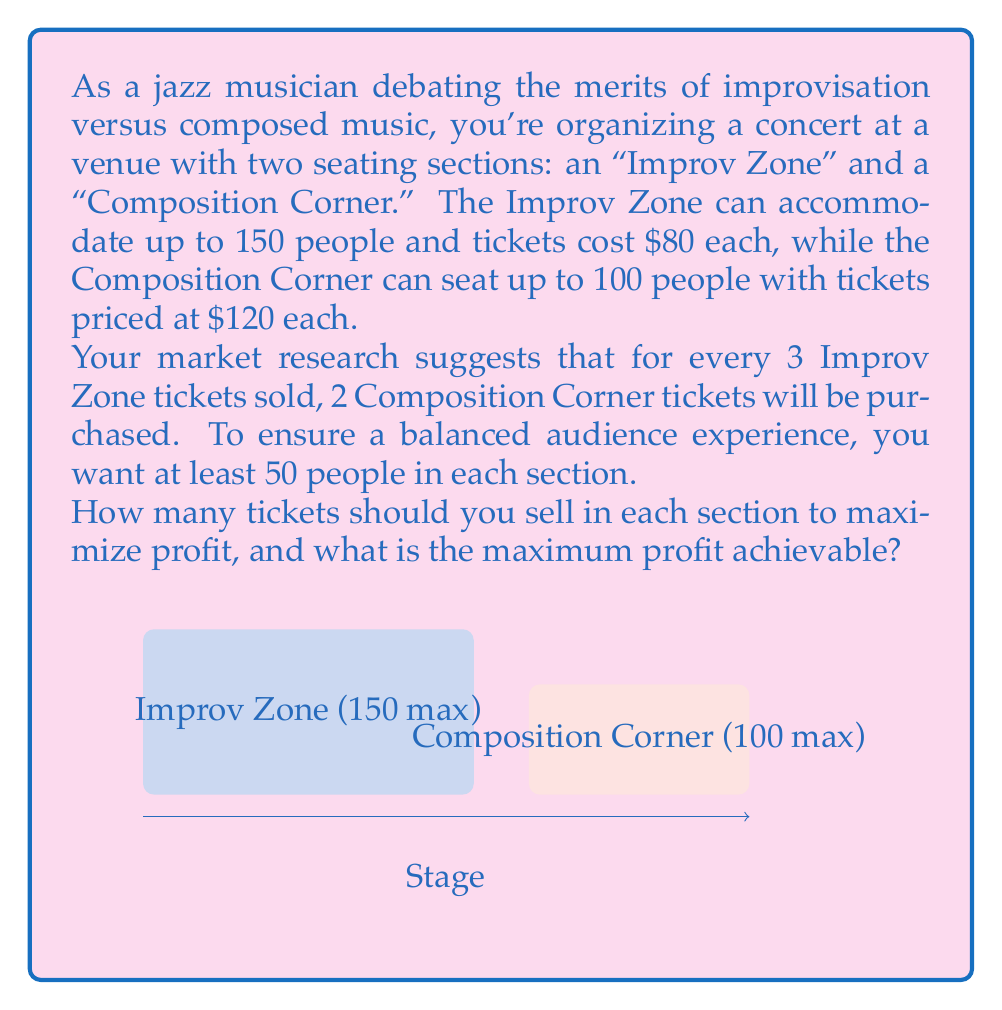Provide a solution to this math problem. Let's approach this step-by-step:

1) Define variables:
   Let $x$ = number of Improv Zone tickets
   Let $y$ = number of Composition Corner tickets

2) Set up the objective function (profit):
   Profit = $80x + 120y$

3) Constraints:
   a) Capacity constraints:
      $x \leq 150$
      $y \leq 100$
   b) Minimum attendance:
      $x \geq 50$
      $y \geq 50$
   c) Sales ratio:
      $\frac{x}{3} = \frac{y}{2}$ or $2x = 3y$

4) From the sales ratio constraint, we can express $x$ in terms of $y$:
   $x = \frac{3y}{2}$

5) Substitute this into the profit function:
   Profit = $80(\frac{3y}{2}) + 120y = 120y + 120y = 240y$

6) Now, we need to find the maximum value of $y$ that satisfies all constraints:
   - From $y \leq 100$, we get $y \leq 100$
   - From $x \leq 150$, we get $\frac{3y}{2} \leq 150$, or $y \leq 100$
   - From $x \geq 50$, we get $\frac{3y}{2} \geq 50$, or $y \geq 33.33$
   - We already have $y \geq 50$ as a constraint

7) The binding constraint is $y \leq 100$, so the maximum value of $y$ is 100.

8) If $y = 100$, then $x = \frac{3(100)}{2} = 150$

9) Maximum profit = $240(100) = 24,000$

Therefore, to maximize profit, sell 150 Improv Zone tickets and 100 Composition Corner tickets.
Answer: 150 Improv Zone tickets, 100 Composition Corner tickets; $24,000 maximum profit 